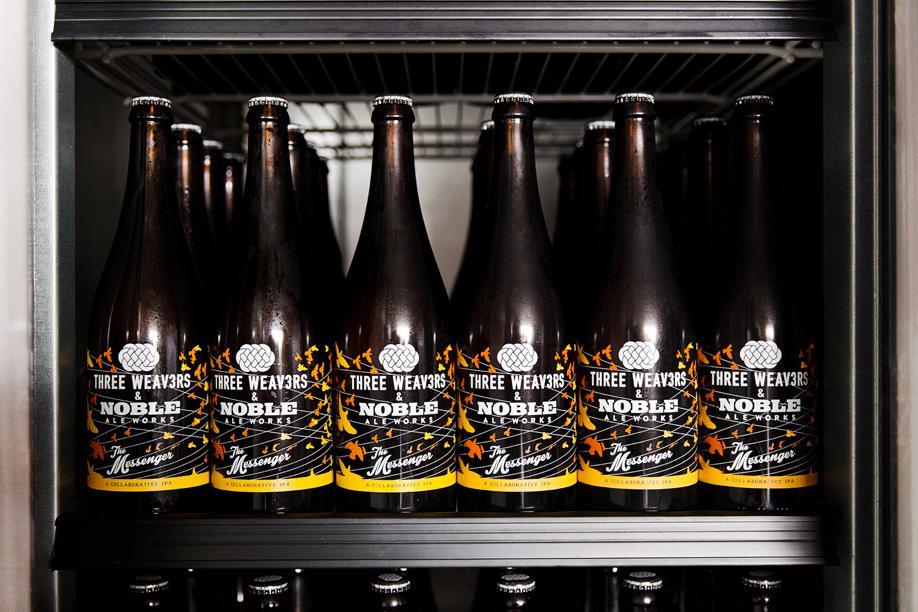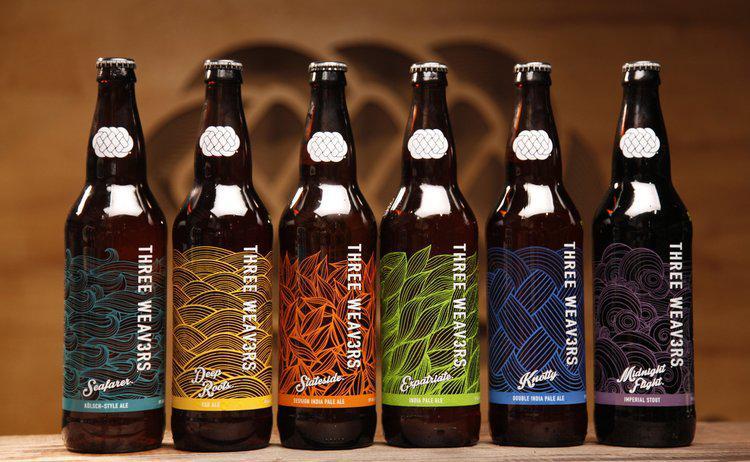The first image is the image on the left, the second image is the image on the right. Considering the images on both sides, is "In one image, bottles of ale fill the shelf of a cooler." valid? Answer yes or no. Yes. 